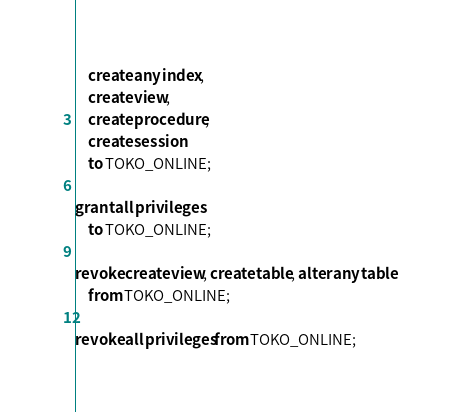Convert code to text. <code><loc_0><loc_0><loc_500><loc_500><_SQL_>    create any index,
    create view,
    create procedure,
    create session
    to TOKO_ONLINE;

grant all privileges
    to TOKO_ONLINE;

revoke create view, create table, alter any table
    from TOKO_ONLINE;

revoke all privileges from TOKO_ONLINE;
</code> 